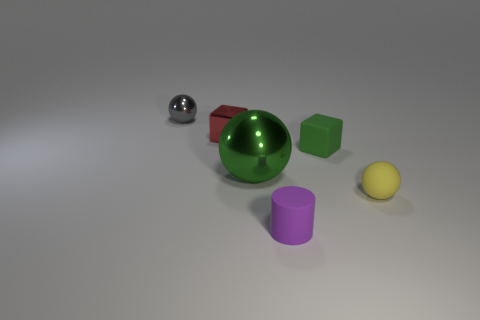Are any blue objects visible? Upon close inspection of the image, it appears there are no blue objects present. The objects consist of various colors including a green sphere, a yellow sphere, a red cylinder, a purple cylinder, and a silver sphere, but blue is not represented amongst them. 